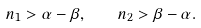<formula> <loc_0><loc_0><loc_500><loc_500>n _ { 1 } > \alpha - \beta , \quad n _ { 2 } > \beta - \alpha .</formula> 